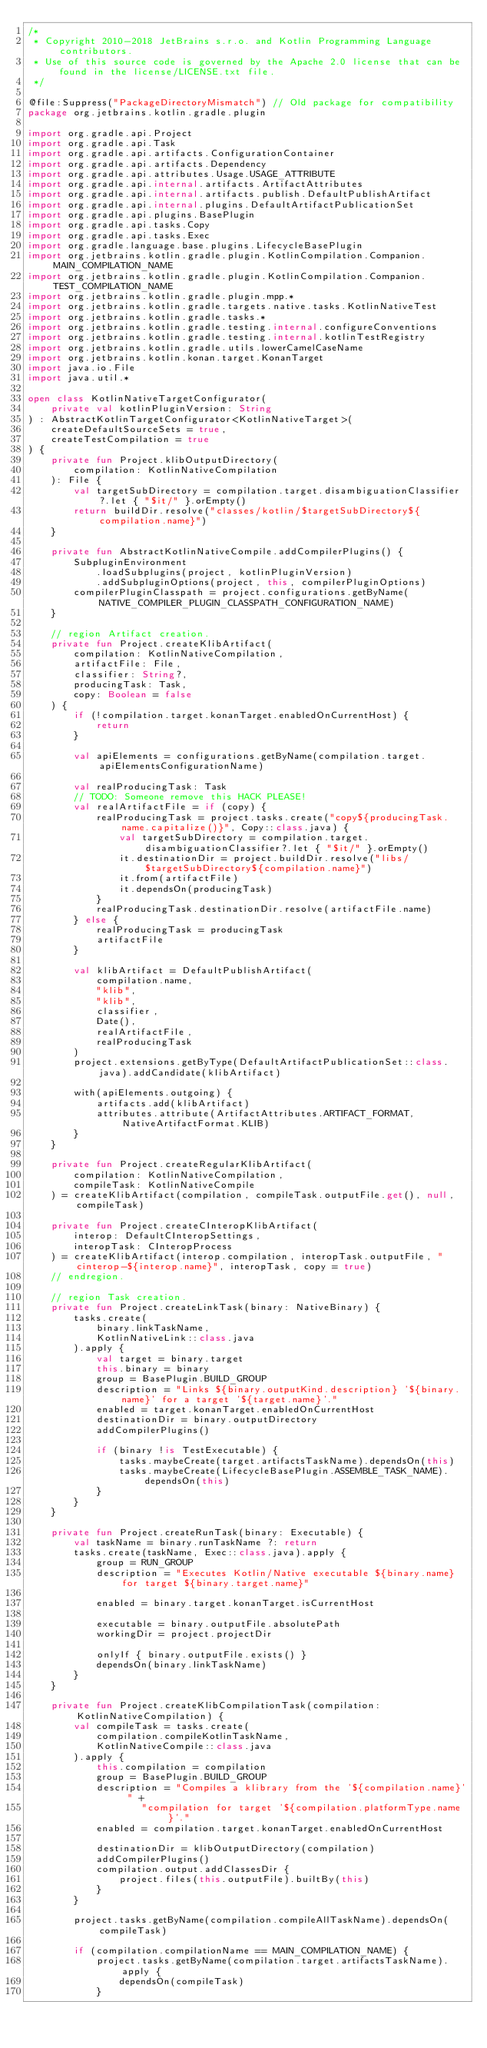Convert code to text. <code><loc_0><loc_0><loc_500><loc_500><_Kotlin_>/*
 * Copyright 2010-2018 JetBrains s.r.o. and Kotlin Programming Language contributors.
 * Use of this source code is governed by the Apache 2.0 license that can be found in the license/LICENSE.txt file.
 */

@file:Suppress("PackageDirectoryMismatch") // Old package for compatibility
package org.jetbrains.kotlin.gradle.plugin

import org.gradle.api.Project
import org.gradle.api.Task
import org.gradle.api.artifacts.ConfigurationContainer
import org.gradle.api.artifacts.Dependency
import org.gradle.api.attributes.Usage.USAGE_ATTRIBUTE
import org.gradle.api.internal.artifacts.ArtifactAttributes
import org.gradle.api.internal.artifacts.publish.DefaultPublishArtifact
import org.gradle.api.internal.plugins.DefaultArtifactPublicationSet
import org.gradle.api.plugins.BasePlugin
import org.gradle.api.tasks.Copy
import org.gradle.api.tasks.Exec
import org.gradle.language.base.plugins.LifecycleBasePlugin
import org.jetbrains.kotlin.gradle.plugin.KotlinCompilation.Companion.MAIN_COMPILATION_NAME
import org.jetbrains.kotlin.gradle.plugin.KotlinCompilation.Companion.TEST_COMPILATION_NAME
import org.jetbrains.kotlin.gradle.plugin.mpp.*
import org.jetbrains.kotlin.gradle.targets.native.tasks.KotlinNativeTest
import org.jetbrains.kotlin.gradle.tasks.*
import org.jetbrains.kotlin.gradle.testing.internal.configureConventions
import org.jetbrains.kotlin.gradle.testing.internal.kotlinTestRegistry
import org.jetbrains.kotlin.gradle.utils.lowerCamelCaseName
import org.jetbrains.kotlin.konan.target.KonanTarget
import java.io.File
import java.util.*

open class KotlinNativeTargetConfigurator(
    private val kotlinPluginVersion: String
) : AbstractKotlinTargetConfigurator<KotlinNativeTarget>(
    createDefaultSourceSets = true,
    createTestCompilation = true
) {
    private fun Project.klibOutputDirectory(
        compilation: KotlinNativeCompilation
    ): File {
        val targetSubDirectory = compilation.target.disambiguationClassifier?.let { "$it/" }.orEmpty()
        return buildDir.resolve("classes/kotlin/$targetSubDirectory${compilation.name}")
    }

    private fun AbstractKotlinNativeCompile.addCompilerPlugins() {
        SubpluginEnvironment
            .loadSubplugins(project, kotlinPluginVersion)
            .addSubpluginOptions(project, this, compilerPluginOptions)
        compilerPluginClasspath = project.configurations.getByName(NATIVE_COMPILER_PLUGIN_CLASSPATH_CONFIGURATION_NAME)
    }

    // region Artifact creation.
    private fun Project.createKlibArtifact(
        compilation: KotlinNativeCompilation,
        artifactFile: File,
        classifier: String?,
        producingTask: Task,
        copy: Boolean = false
    ) {
        if (!compilation.target.konanTarget.enabledOnCurrentHost) {
            return
        }

        val apiElements = configurations.getByName(compilation.target.apiElementsConfigurationName)

        val realProducingTask: Task
        // TODO: Someone remove this HACK PLEASE!
        val realArtifactFile = if (copy) {
            realProducingTask = project.tasks.create("copy${producingTask.name.capitalize()}", Copy::class.java) {
                val targetSubDirectory = compilation.target.disambiguationClassifier?.let { "$it/" }.orEmpty()
                it.destinationDir = project.buildDir.resolve("libs/$targetSubDirectory${compilation.name}")
                it.from(artifactFile)
                it.dependsOn(producingTask)
            }
            realProducingTask.destinationDir.resolve(artifactFile.name)
        } else {
            realProducingTask = producingTask
            artifactFile
        }

        val klibArtifact = DefaultPublishArtifact(
            compilation.name,
            "klib",
            "klib",
            classifier,
            Date(),
            realArtifactFile,
            realProducingTask
        )
        project.extensions.getByType(DefaultArtifactPublicationSet::class.java).addCandidate(klibArtifact)

        with(apiElements.outgoing) {
            artifacts.add(klibArtifact)
            attributes.attribute(ArtifactAttributes.ARTIFACT_FORMAT, NativeArtifactFormat.KLIB)
        }
    }

    private fun Project.createRegularKlibArtifact(
        compilation: KotlinNativeCompilation,
        compileTask: KotlinNativeCompile
    ) = createKlibArtifact(compilation, compileTask.outputFile.get(), null, compileTask)

    private fun Project.createCInteropKlibArtifact(
        interop: DefaultCInteropSettings,
        interopTask: CInteropProcess
    ) = createKlibArtifact(interop.compilation, interopTask.outputFile, "cinterop-${interop.name}", interopTask, copy = true)
    // endregion.

    // region Task creation.
    private fun Project.createLinkTask(binary: NativeBinary) {
        tasks.create(
            binary.linkTaskName,
            KotlinNativeLink::class.java
        ).apply {
            val target = binary.target
            this.binary = binary
            group = BasePlugin.BUILD_GROUP
            description = "Links ${binary.outputKind.description} '${binary.name}' for a target '${target.name}'."
            enabled = target.konanTarget.enabledOnCurrentHost
            destinationDir = binary.outputDirectory
            addCompilerPlugins()

            if (binary !is TestExecutable) {
                tasks.maybeCreate(target.artifactsTaskName).dependsOn(this)
                tasks.maybeCreate(LifecycleBasePlugin.ASSEMBLE_TASK_NAME).dependsOn(this)
            }
        }
    }

    private fun Project.createRunTask(binary: Executable) {
        val taskName = binary.runTaskName ?: return
        tasks.create(taskName, Exec::class.java).apply {
            group = RUN_GROUP
            description = "Executes Kotlin/Native executable ${binary.name} for target ${binary.target.name}"

            enabled = binary.target.konanTarget.isCurrentHost

            executable = binary.outputFile.absolutePath
            workingDir = project.projectDir

            onlyIf { binary.outputFile.exists() }
            dependsOn(binary.linkTaskName)
        }
    }

    private fun Project.createKlibCompilationTask(compilation: KotlinNativeCompilation) {
        val compileTask = tasks.create(
            compilation.compileKotlinTaskName,
            KotlinNativeCompile::class.java
        ).apply {
            this.compilation = compilation
            group = BasePlugin.BUILD_GROUP
            description = "Compiles a klibrary from the '${compilation.name}' " +
                    "compilation for target '${compilation.platformType.name}'."
            enabled = compilation.target.konanTarget.enabledOnCurrentHost

            destinationDir = klibOutputDirectory(compilation)
            addCompilerPlugins()
            compilation.output.addClassesDir {
                project.files(this.outputFile).builtBy(this)
            }
        }

        project.tasks.getByName(compilation.compileAllTaskName).dependsOn(compileTask)

        if (compilation.compilationName == MAIN_COMPILATION_NAME) {
            project.tasks.getByName(compilation.target.artifactsTaskName).apply {
                dependsOn(compileTask)
            }</code> 